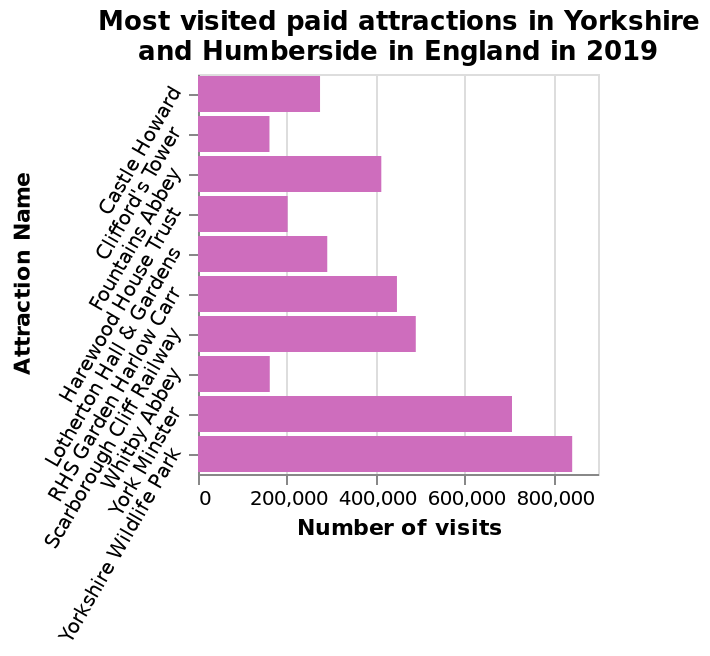<image>
How many attractions are plotted on the y-axis of the bar plot?  There are multiple attractions plotted on the y-axis of the bar plot, including Castle Howard and Yorkshire Wildlife Park. 